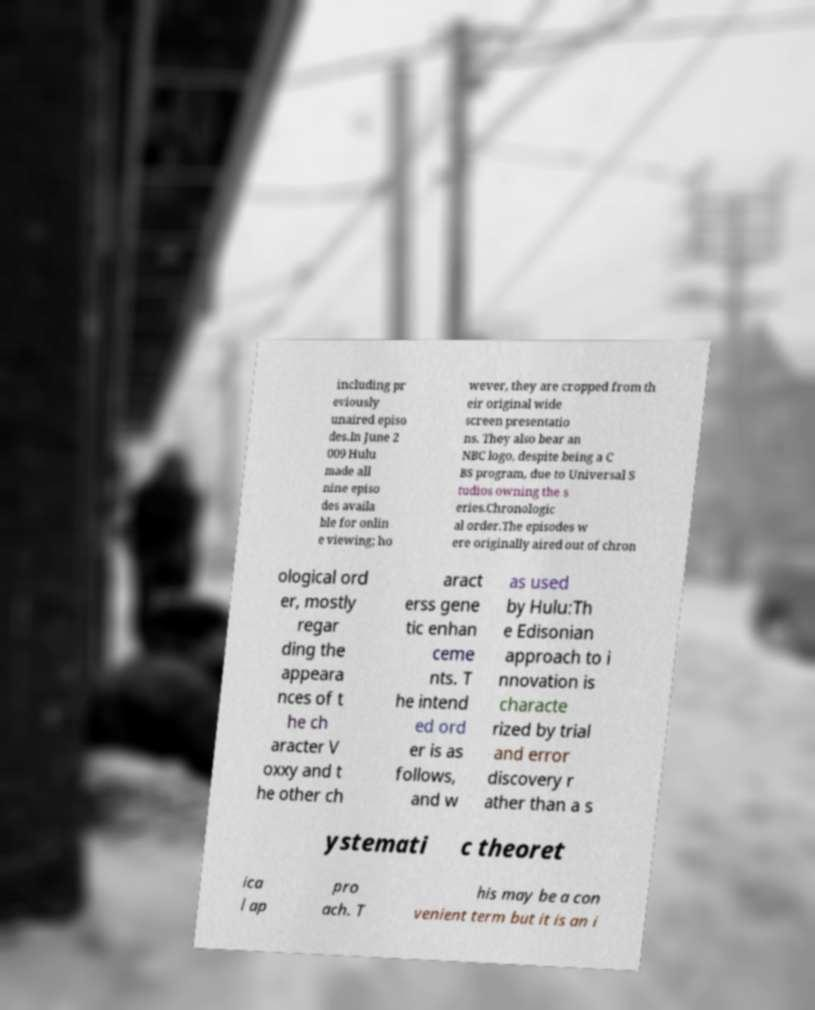Can you accurately transcribe the text from the provided image for me? including pr eviously unaired episo des.In June 2 009 Hulu made all nine episo des availa ble for onlin e viewing; ho wever, they are cropped from th eir original wide screen presentatio ns. They also bear an NBC logo, despite being a C BS program, due to Universal S tudios owning the s eries.Chronologic al order.The episodes w ere originally aired out of chron ological ord er, mostly regar ding the appeara nces of t he ch aracter V oxxy and t he other ch aract erss gene tic enhan ceme nts. T he intend ed ord er is as follows, and w as used by Hulu:Th e Edisonian approach to i nnovation is characte rized by trial and error discovery r ather than a s ystemati c theoret ica l ap pro ach. T his may be a con venient term but it is an i 